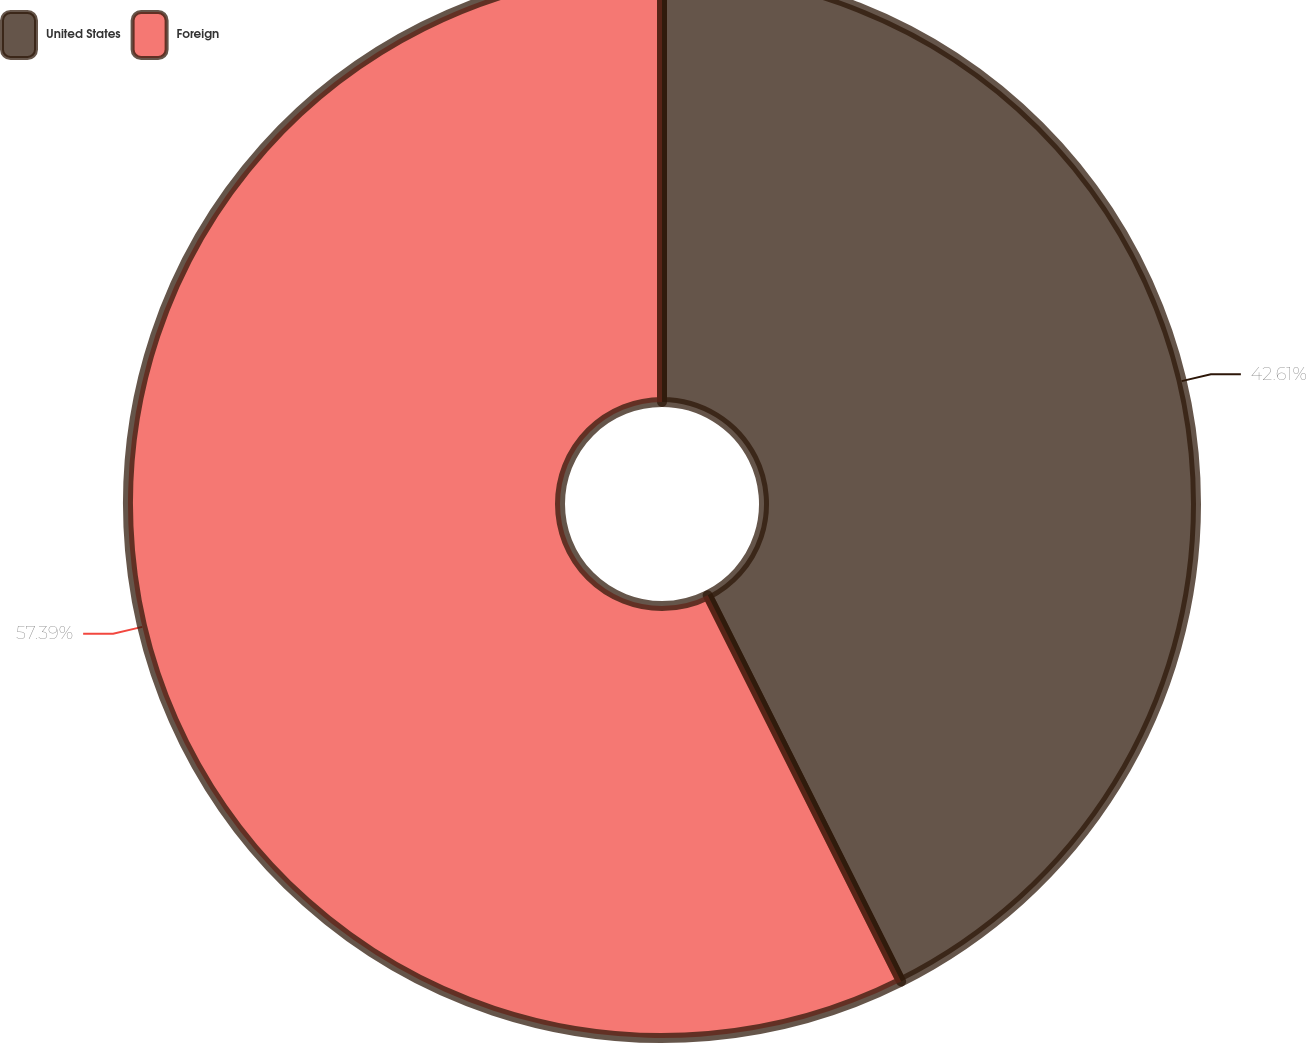<chart> <loc_0><loc_0><loc_500><loc_500><pie_chart><fcel>United States<fcel>Foreign<nl><fcel>42.61%<fcel>57.39%<nl></chart> 